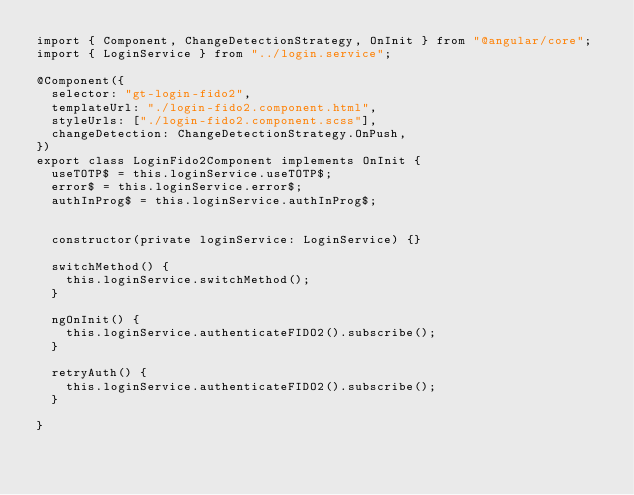Convert code to text. <code><loc_0><loc_0><loc_500><loc_500><_TypeScript_>import { Component, ChangeDetectionStrategy, OnInit } from "@angular/core";
import { LoginService } from "../login.service";

@Component({
  selector: "gt-login-fido2",
  templateUrl: "./login-fido2.component.html",
  styleUrls: ["./login-fido2.component.scss"],
  changeDetection: ChangeDetectionStrategy.OnPush,
})
export class LoginFido2Component implements OnInit {
  useTOTP$ = this.loginService.useTOTP$;
  error$ = this.loginService.error$;
  authInProg$ = this.loginService.authInProg$;


  constructor(private loginService: LoginService) {}

  switchMethod() {
    this.loginService.switchMethod();
  }

  ngOnInit() {
    this.loginService.authenticateFIDO2().subscribe();
  }

  retryAuth() {
    this.loginService.authenticateFIDO2().subscribe();
  }

}
</code> 